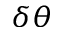Convert formula to latex. <formula><loc_0><loc_0><loc_500><loc_500>\delta \theta</formula> 